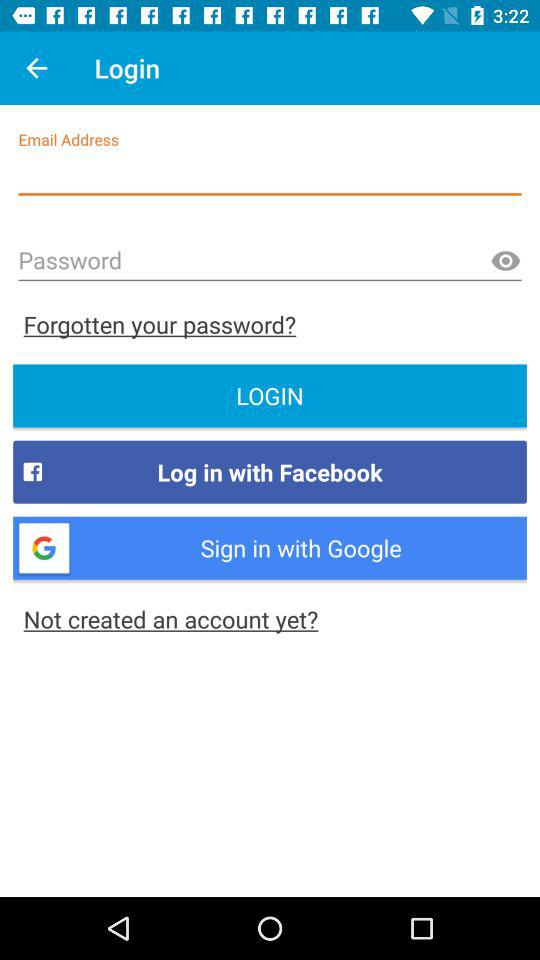How many text input fields are there on the login page?
Answer the question using a single word or phrase. 2 